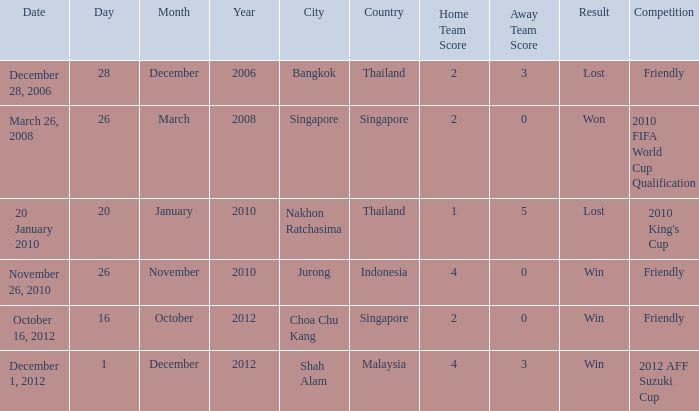Could you parse the entire table? {'header': ['Date', 'Day', 'Month', 'Year', 'City', 'Country', 'Home Team Score', 'Away Team Score', 'Result', 'Competition'], 'rows': [['December 28, 2006', '28', 'December', '2006', 'Bangkok', 'Thailand', '2', '3', 'Lost', 'Friendly'], ['March 26, 2008', '26', 'March', '2008', 'Singapore', 'Singapore', '2', '0', 'Won', '2010 FIFA World Cup Qualification'], ['20 January 2010', '20', 'January', '2010', 'Nakhon Ratchasima', 'Thailand', '1', '5', 'Lost', "2010 King's Cup"], ['November 26, 2010', '26', 'November', '2010', 'Jurong', 'Indonesia', '4', '0', 'Win', 'Friendly'], ['October 16, 2012', '16', 'October', '2012', 'Choa Chu Kang', 'Singapore', '2', '0', 'Win', 'Friendly'], ['December 1, 2012', '1', 'December', '2012', 'Shah Alam', 'Malaysia', '4', '3', 'Win', '2012 AFF Suzuki Cup']]} Name the date for score of 1-5 20 January 2010. 